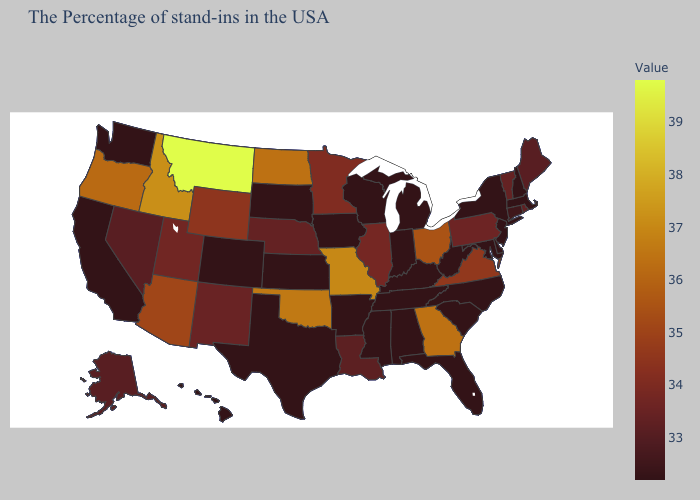Which states hav the highest value in the West?
Quick response, please. Montana. Does the map have missing data?
Write a very short answer. No. 